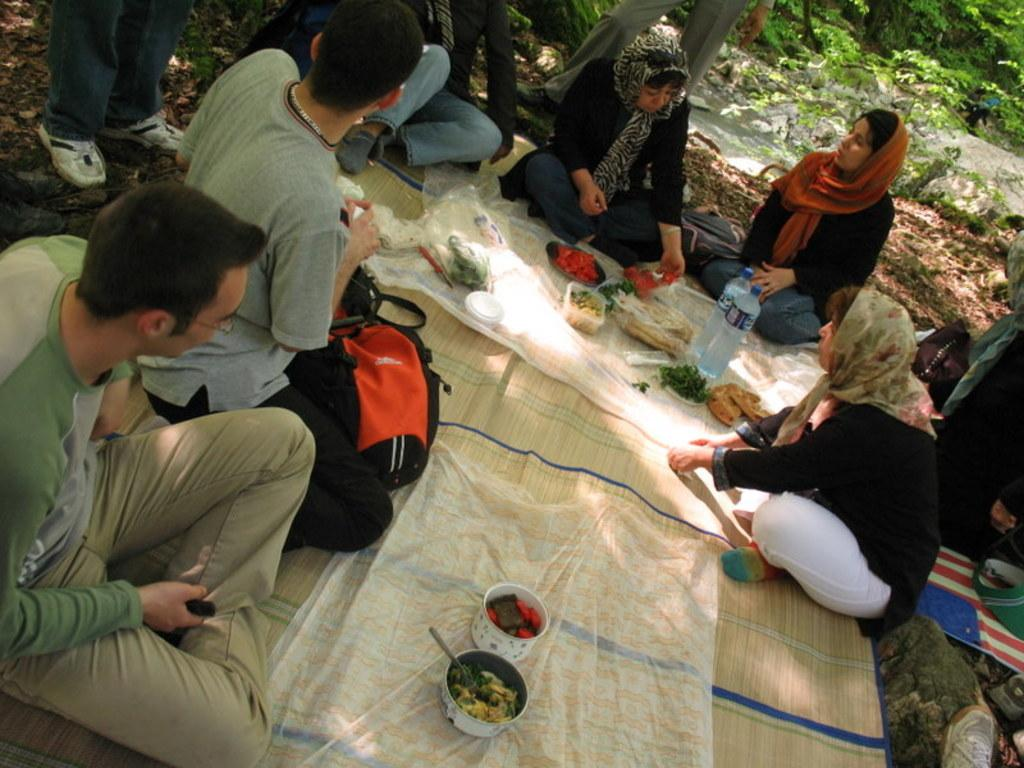What are the people in the image doing? There is a group of persons sitting on the ground. What items can be seen on the mat? There are bottles, food, and bowls on the mat. What can be seen in the background of the image? There is water and plants visible in the background, as well as persons. How many rabbits are hopping around the persons sitting on the ground? There are no rabbits present in the image; it only shows a group of persons sitting on the ground, bottles, food, and bowls on the mat, and water, plants, and persons in the background. 